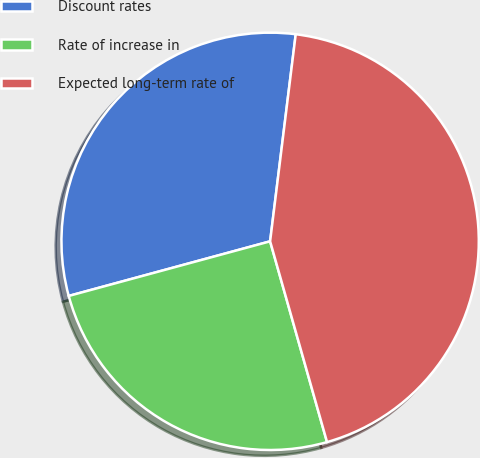Convert chart to OTSL. <chart><loc_0><loc_0><loc_500><loc_500><pie_chart><fcel>Discount rates<fcel>Rate of increase in<fcel>Expected long-term rate of<nl><fcel>31.17%<fcel>25.18%<fcel>43.64%<nl></chart> 